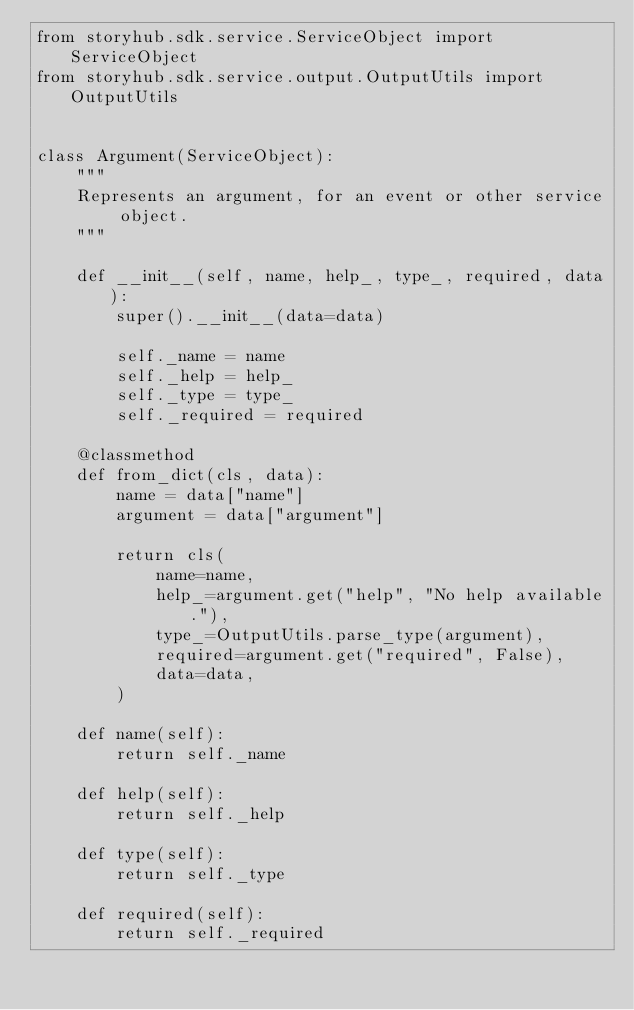Convert code to text. <code><loc_0><loc_0><loc_500><loc_500><_Python_>from storyhub.sdk.service.ServiceObject import ServiceObject
from storyhub.sdk.service.output.OutputUtils import OutputUtils


class Argument(ServiceObject):
    """
    Represents an argument, for an event or other service object.
    """

    def __init__(self, name, help_, type_, required, data):
        super().__init__(data=data)

        self._name = name
        self._help = help_
        self._type = type_
        self._required = required

    @classmethod
    def from_dict(cls, data):
        name = data["name"]
        argument = data["argument"]

        return cls(
            name=name,
            help_=argument.get("help", "No help available."),
            type_=OutputUtils.parse_type(argument),
            required=argument.get("required", False),
            data=data,
        )

    def name(self):
        return self._name

    def help(self):
        return self._help

    def type(self):
        return self._type

    def required(self):
        return self._required
</code> 